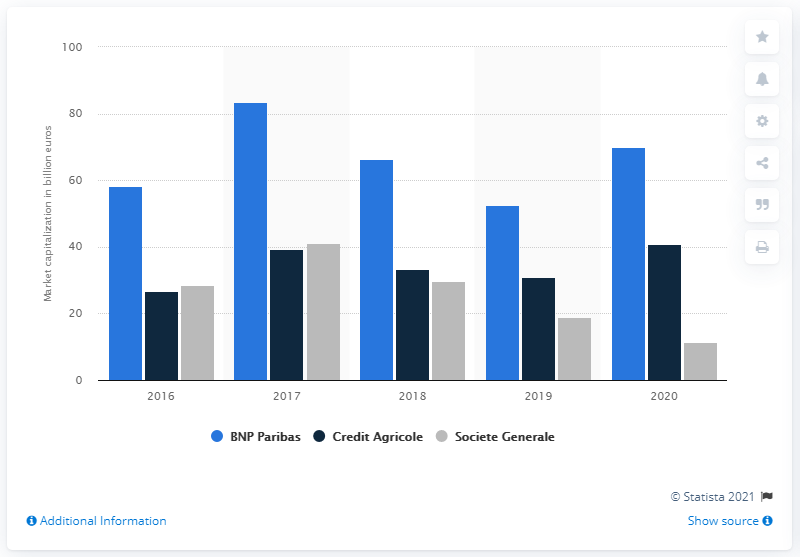Draw attention to some important aspects in this diagram. As of January 2020, BNP Paribas' market capital was 69.83... BNP Paribas was the leading French bank with the largest market capitalization among all the leading banks in the country. 